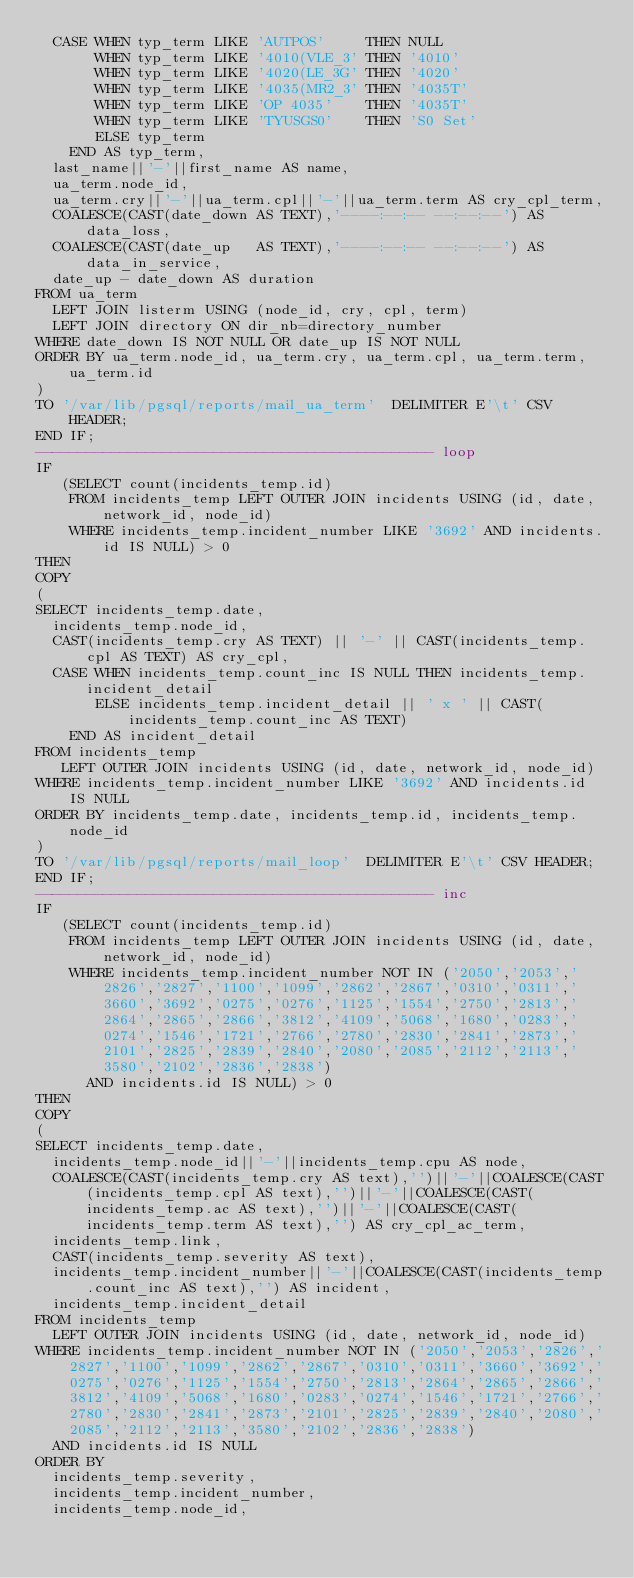<code> <loc_0><loc_0><loc_500><loc_500><_SQL_>  CASE WHEN typ_term LIKE 'AUTPOS'     THEN NULL
       WHEN typ_term LIKE '4010(VLE_3' THEN '4010'
       WHEN typ_term LIKE '4020(LE_3G' THEN '4020'
       WHEN typ_term LIKE '4035(MR2_3' THEN '4035T'
       WHEN typ_term LIKE 'OP 4035'    THEN '4035T'
       WHEN typ_term LIKE 'TYUSGS0'    THEN 'S0 Set'
       ELSE typ_term 
    END AS typ_term,
  last_name||'-'||first_name AS name, 
  ua_term.node_id, 
  ua_term.cry||'-'||ua_term.cpl||'-'||ua_term.term AS cry_cpl_term, 
  COALESCE(CAST(date_down AS TEXT),'----:--:-- --:--:--') AS data_loss, 
  COALESCE(CAST(date_up   AS TEXT),'----:--:-- --:--:--') AS data_in_service,
  date_up - date_down AS duration
FROM ua_term 
  LEFT JOIN listerm USING (node_id, cry, cpl, term)
  LEFT JOIN directory ON dir_nb=directory_number
WHERE date_down IS NOT NULL OR date_up IS NOT NULL
ORDER BY ua_term.node_id, ua_term.cry, ua_term.cpl, ua_term.term, ua_term.id 
) 
TO '/var/lib/pgsql/reports/mail_ua_term'  DELIMITER E'\t' CSV HEADER;
END IF;
----------------------------------------------- loop
IF 
   (SELECT count(incidents_temp.id)
    FROM incidents_temp LEFT OUTER JOIN incidents USING (id, date, network_id, node_id)
    WHERE incidents_temp.incident_number LIKE '3692' AND incidents.id IS NULL) > 0
THEN
COPY 
( 
SELECT incidents_temp.date,
  incidents_temp.node_id,
  CAST(incidents_temp.cry AS TEXT) || '-' || CAST(incidents_temp.cpl AS TEXT) AS cry_cpl,
  CASE WHEN incidents_temp.count_inc IS NULL THEN incidents_temp.incident_detail
       ELSE incidents_temp.incident_detail || ' x ' || CAST(incidents_temp.count_inc AS TEXT) 
    END AS incident_detail
FROM incidents_temp
   LEFT OUTER JOIN incidents USING (id, date, network_id, node_id)
WHERE incidents_temp.incident_number LIKE '3692' AND incidents.id IS NULL
ORDER BY incidents_temp.date, incidents_temp.id, incidents_temp.node_id
) 
TO '/var/lib/pgsql/reports/mail_loop'  DELIMITER E'\t' CSV HEADER;
END IF;
----------------------------------------------- inc
IF 
   (SELECT count(incidents_temp.id)
    FROM incidents_temp LEFT OUTER JOIN incidents USING (id, date, network_id, node_id)
    WHERE incidents_temp.incident_number NOT IN ('2050','2053','2826','2827','1100','1099','2862','2867','0310','0311','3660','3692','0275','0276','1125','1554','2750','2813','2864','2865','2866','3812','4109','5068','1680','0283','0274','1546','1721','2766','2780','2830','2841','2873','2101','2825','2839','2840','2080','2085','2112','2113','3580','2102','2836','2838')
      AND incidents.id IS NULL) > 0
THEN
COPY 
( 
SELECT incidents_temp.date, 
  incidents_temp.node_id||'-'||incidents_temp.cpu AS node, 
  COALESCE(CAST(incidents_temp.cry AS text),'')||'-'||COALESCE(CAST(incidents_temp.cpl AS text),'')||'-'||COALESCE(CAST(incidents_temp.ac AS text),'')||'-'||COALESCE(CAST(incidents_temp.term AS text),'') AS cry_cpl_ac_term,
  incidents_temp.link, 
  CAST(incidents_temp.severity AS text), 
  incidents_temp.incident_number||'-'||COALESCE(CAST(incidents_temp.count_inc AS text),'') AS incident, 
  incidents_temp.incident_detail 
FROM incidents_temp
  LEFT OUTER JOIN incidents USING (id, date, network_id, node_id)
WHERE incidents_temp.incident_number NOT IN ('2050','2053','2826','2827','1100','1099','2862','2867','0310','0311','3660','3692','0275','0276','1125','1554','2750','2813','2864','2865','2866','3812','4109','5068','1680','0283','0274','1546','1721','2766','2780','2830','2841','2873','2101','2825','2839','2840','2080','2085','2112','2113','3580','2102','2836','2838')
  AND incidents.id IS NULL
ORDER BY 
  incidents_temp.severity, 
  incidents_temp.incident_number, 
  incidents_temp.node_id, </code> 